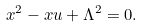Convert formula to latex. <formula><loc_0><loc_0><loc_500><loc_500>x ^ { 2 } - x u + \Lambda ^ { 2 } = 0 .</formula> 